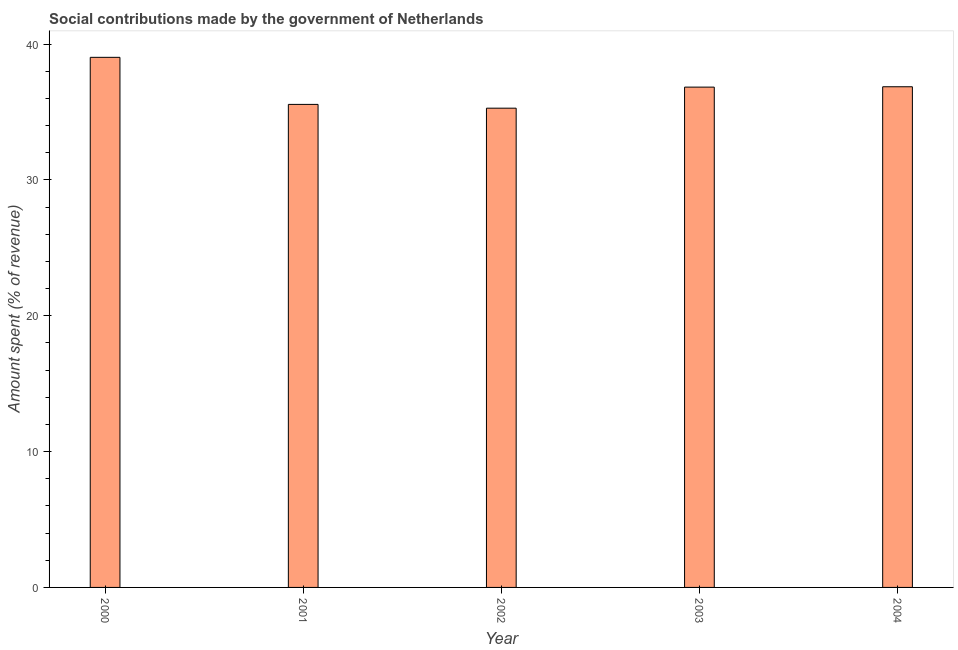Does the graph contain any zero values?
Ensure brevity in your answer.  No. What is the title of the graph?
Ensure brevity in your answer.  Social contributions made by the government of Netherlands. What is the label or title of the Y-axis?
Your answer should be very brief. Amount spent (% of revenue). What is the amount spent in making social contributions in 2004?
Keep it short and to the point. 36.86. Across all years, what is the maximum amount spent in making social contributions?
Give a very brief answer. 39.03. Across all years, what is the minimum amount spent in making social contributions?
Give a very brief answer. 35.29. In which year was the amount spent in making social contributions minimum?
Make the answer very short. 2002. What is the sum of the amount spent in making social contributions?
Make the answer very short. 183.58. What is the difference between the amount spent in making social contributions in 2000 and 2002?
Give a very brief answer. 3.74. What is the average amount spent in making social contributions per year?
Your answer should be compact. 36.72. What is the median amount spent in making social contributions?
Keep it short and to the point. 36.84. In how many years, is the amount spent in making social contributions greater than 14 %?
Your answer should be compact. 5. Do a majority of the years between 2002 and 2003 (inclusive) have amount spent in making social contributions greater than 4 %?
Offer a terse response. Yes. What is the ratio of the amount spent in making social contributions in 2000 to that in 2003?
Offer a very short reply. 1.06. Is the amount spent in making social contributions in 2001 less than that in 2002?
Your answer should be compact. No. What is the difference between the highest and the second highest amount spent in making social contributions?
Provide a short and direct response. 2.17. Is the sum of the amount spent in making social contributions in 2000 and 2002 greater than the maximum amount spent in making social contributions across all years?
Give a very brief answer. Yes. What is the difference between the highest and the lowest amount spent in making social contributions?
Ensure brevity in your answer.  3.74. How many bars are there?
Your answer should be compact. 5. Are all the bars in the graph horizontal?
Make the answer very short. No. What is the Amount spent (% of revenue) of 2000?
Keep it short and to the point. 39.03. What is the Amount spent (% of revenue) of 2001?
Ensure brevity in your answer.  35.56. What is the Amount spent (% of revenue) in 2002?
Offer a very short reply. 35.29. What is the Amount spent (% of revenue) of 2003?
Keep it short and to the point. 36.84. What is the Amount spent (% of revenue) in 2004?
Offer a terse response. 36.86. What is the difference between the Amount spent (% of revenue) in 2000 and 2001?
Your answer should be very brief. 3.47. What is the difference between the Amount spent (% of revenue) in 2000 and 2002?
Keep it short and to the point. 3.74. What is the difference between the Amount spent (% of revenue) in 2000 and 2003?
Ensure brevity in your answer.  2.19. What is the difference between the Amount spent (% of revenue) in 2000 and 2004?
Provide a short and direct response. 2.17. What is the difference between the Amount spent (% of revenue) in 2001 and 2002?
Your answer should be compact. 0.28. What is the difference between the Amount spent (% of revenue) in 2001 and 2003?
Provide a short and direct response. -1.27. What is the difference between the Amount spent (% of revenue) in 2001 and 2004?
Your answer should be compact. -1.3. What is the difference between the Amount spent (% of revenue) in 2002 and 2003?
Give a very brief answer. -1.55. What is the difference between the Amount spent (% of revenue) in 2002 and 2004?
Provide a short and direct response. -1.58. What is the difference between the Amount spent (% of revenue) in 2003 and 2004?
Your response must be concise. -0.03. What is the ratio of the Amount spent (% of revenue) in 2000 to that in 2001?
Provide a short and direct response. 1.1. What is the ratio of the Amount spent (% of revenue) in 2000 to that in 2002?
Offer a very short reply. 1.11. What is the ratio of the Amount spent (% of revenue) in 2000 to that in 2003?
Ensure brevity in your answer.  1.06. What is the ratio of the Amount spent (% of revenue) in 2000 to that in 2004?
Ensure brevity in your answer.  1.06. What is the ratio of the Amount spent (% of revenue) in 2001 to that in 2002?
Give a very brief answer. 1.01. What is the ratio of the Amount spent (% of revenue) in 2002 to that in 2003?
Your answer should be very brief. 0.96. 